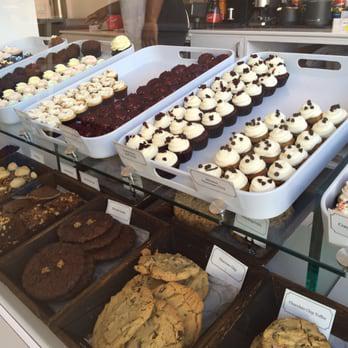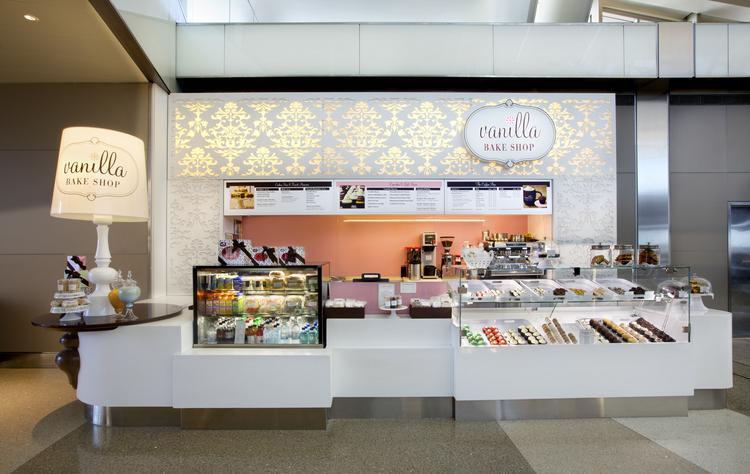The first image is the image on the left, the second image is the image on the right. Evaluate the accuracy of this statement regarding the images: "There is a lampshade that says """"Vanilla Bake Shop""""". Is it true? Answer yes or no. Yes. The first image is the image on the left, the second image is the image on the right. Analyze the images presented: Is the assertion "A large table lamp is on top of a brown table next to a display of desserts." valid? Answer yes or no. Yes. 